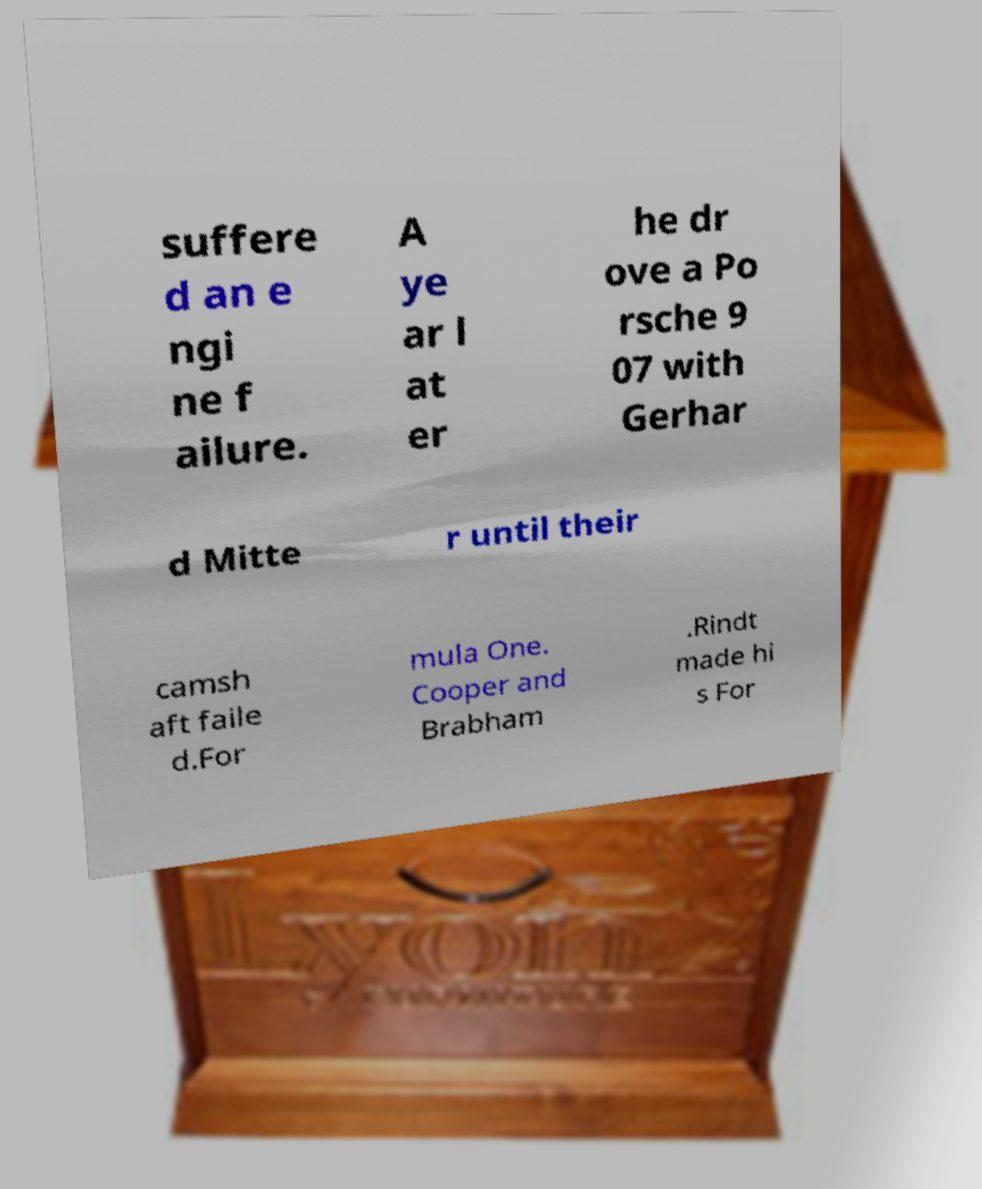Can you read and provide the text displayed in the image?This photo seems to have some interesting text. Can you extract and type it out for me? suffere d an e ngi ne f ailure. A ye ar l at er he dr ove a Po rsche 9 07 with Gerhar d Mitte r until their camsh aft faile d.For mula One. Cooper and Brabham .Rindt made hi s For 